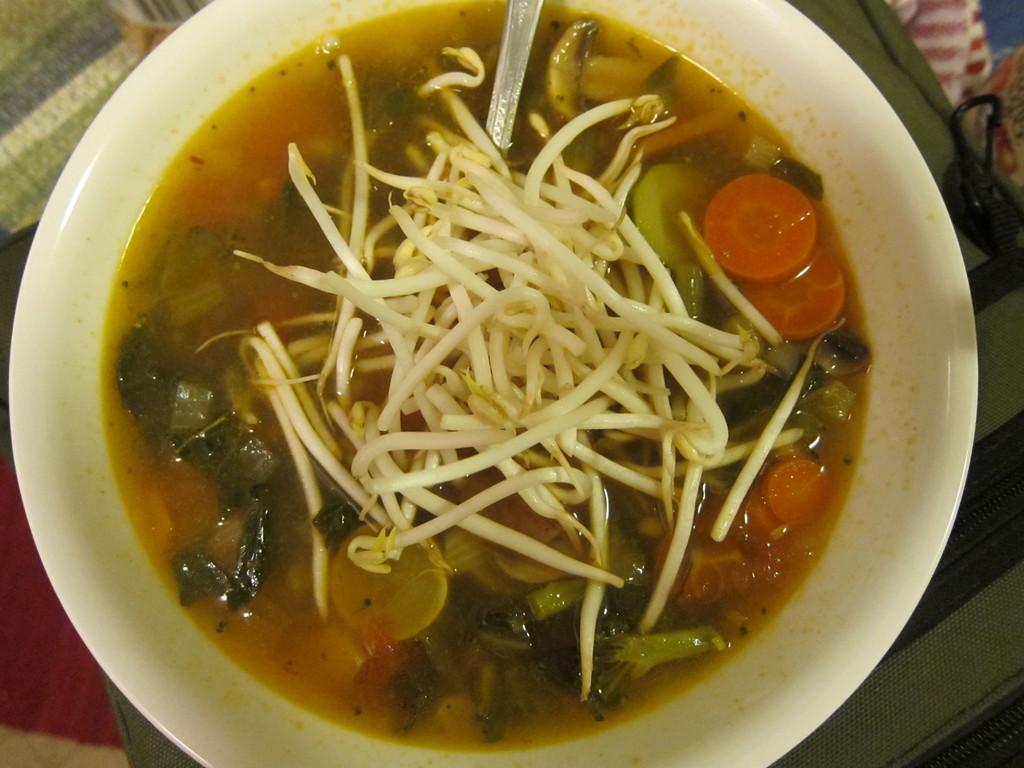Can you describe this image briefly? The picture consists of a food item in a bowl, in the bowl there is a spoon also. At the bottom there is a cloth. 